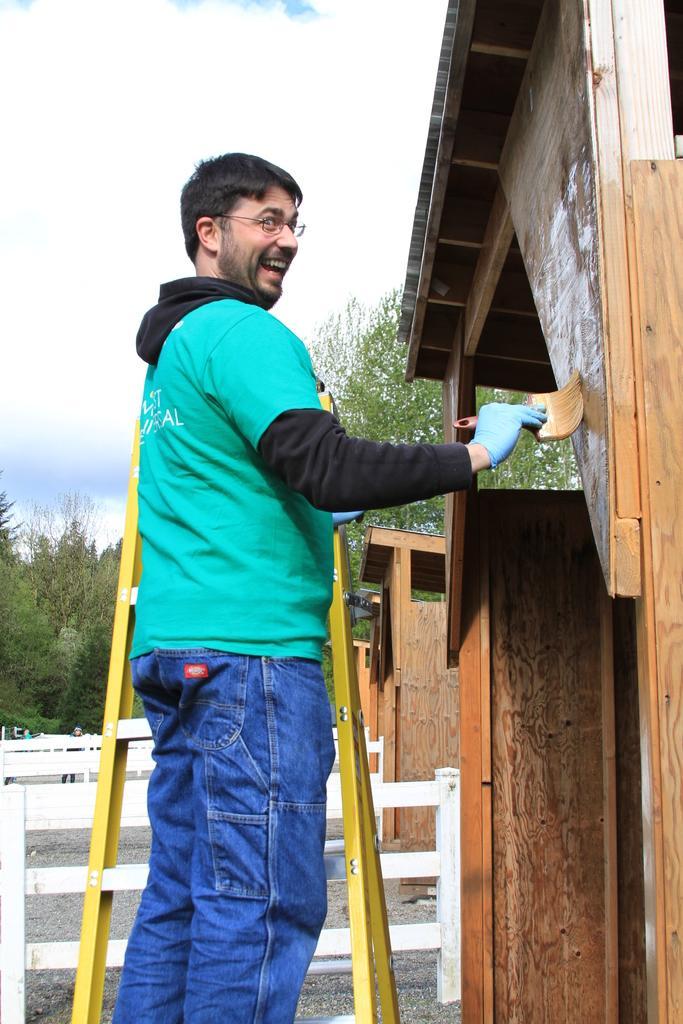How would you summarize this image in a sentence or two? In this image in the front there is a person standing on the ladder and smiling. On the right side there are objects which are made up of wood. In the background there are objects which are white in colour and there are trees and the sky is cloudy. 